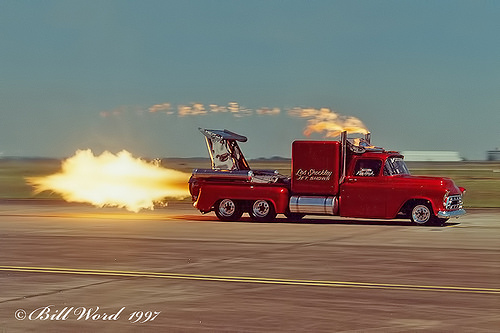<image>
Can you confirm if the floor is under the fire? Yes. The floor is positioned underneath the fire, with the fire above it in the vertical space. 